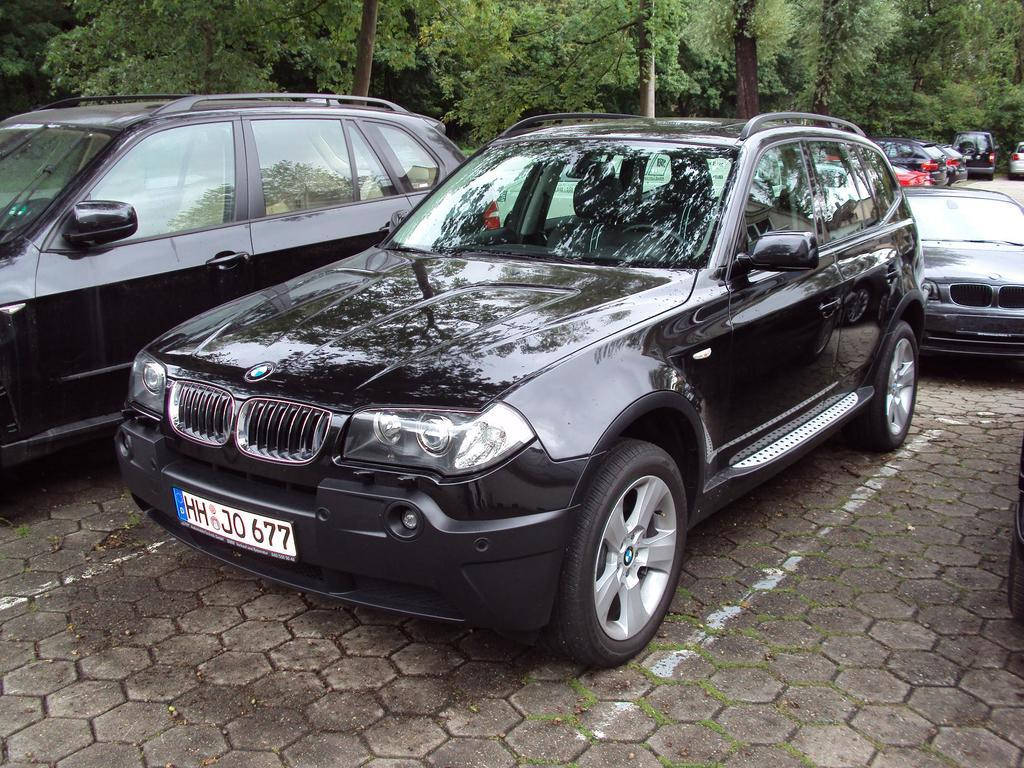What type of natural elements can be seen in the image? There are trees in the image. What type of man-made objects can be seen in the image? There are cars in the image. What is the primary surface visible in the bottom portion of the image? The bottom portion of the image contains a road. What type of attraction is visible in the image? There is no attraction present in the image; it features trees, cars, and a road. What type of cooking utensil can be seen in the image? There is no cooking utensil present in the image. 